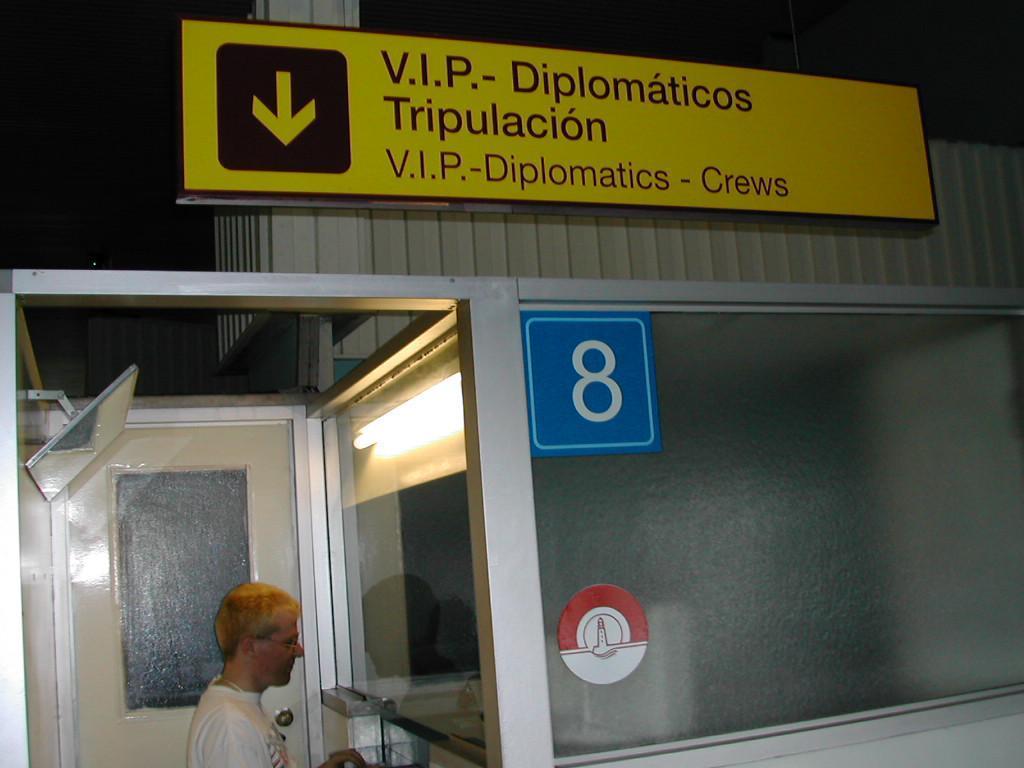Can you describe this image briefly? In this image I can see a yellow board with something written on it. I can see a man standing near the mirror. I can see a door. 